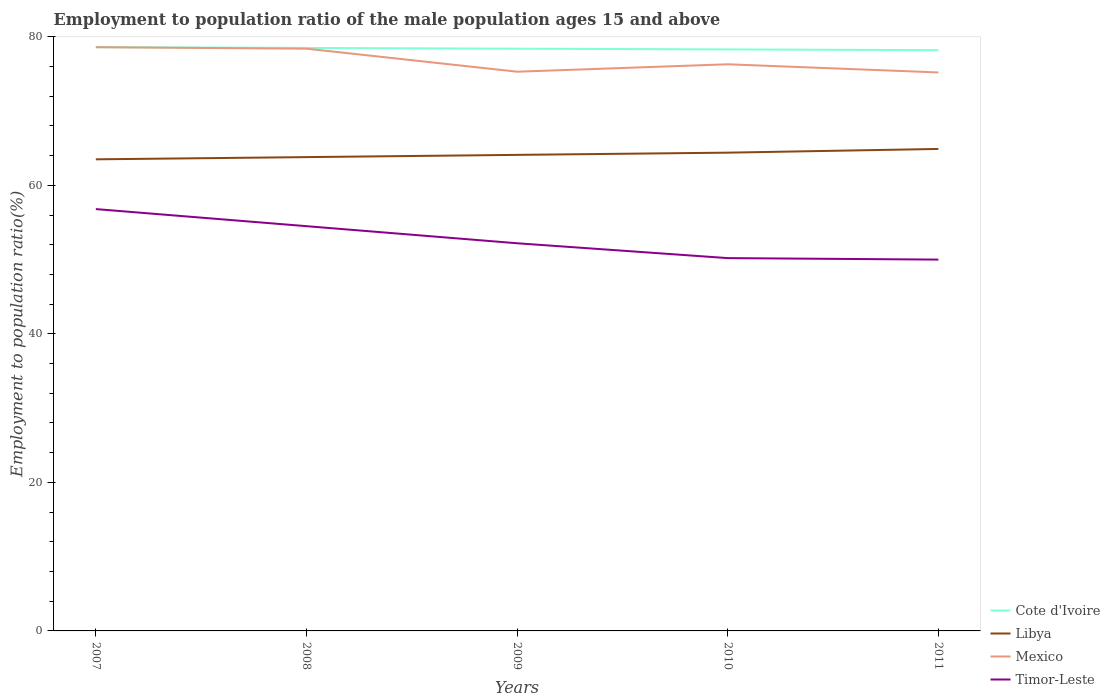How many different coloured lines are there?
Provide a succinct answer. 4. Does the line corresponding to Libya intersect with the line corresponding to Cote d'Ivoire?
Your response must be concise. No. Is the number of lines equal to the number of legend labels?
Provide a short and direct response. Yes. Across all years, what is the maximum employment to population ratio in Mexico?
Keep it short and to the point. 75.2. What is the total employment to population ratio in Mexico in the graph?
Ensure brevity in your answer.  3.1. What is the difference between the highest and the second highest employment to population ratio in Timor-Leste?
Your response must be concise. 6.8. What is the difference between the highest and the lowest employment to population ratio in Cote d'Ivoire?
Your answer should be very brief. 3. How many lines are there?
Offer a terse response. 4. Does the graph contain grids?
Your answer should be very brief. No. How many legend labels are there?
Your answer should be compact. 4. What is the title of the graph?
Provide a succinct answer. Employment to population ratio of the male population ages 15 and above. Does "Kiribati" appear as one of the legend labels in the graph?
Ensure brevity in your answer.  No. What is the label or title of the X-axis?
Your response must be concise. Years. What is the label or title of the Y-axis?
Ensure brevity in your answer.  Employment to population ratio(%). What is the Employment to population ratio(%) of Cote d'Ivoire in 2007?
Ensure brevity in your answer.  78.6. What is the Employment to population ratio(%) in Libya in 2007?
Offer a very short reply. 63.5. What is the Employment to population ratio(%) of Mexico in 2007?
Provide a short and direct response. 78.6. What is the Employment to population ratio(%) of Timor-Leste in 2007?
Your answer should be very brief. 56.8. What is the Employment to population ratio(%) in Cote d'Ivoire in 2008?
Make the answer very short. 78.5. What is the Employment to population ratio(%) in Libya in 2008?
Make the answer very short. 63.8. What is the Employment to population ratio(%) of Mexico in 2008?
Ensure brevity in your answer.  78.4. What is the Employment to population ratio(%) of Timor-Leste in 2008?
Provide a succinct answer. 54.5. What is the Employment to population ratio(%) in Cote d'Ivoire in 2009?
Ensure brevity in your answer.  78.4. What is the Employment to population ratio(%) in Libya in 2009?
Offer a very short reply. 64.1. What is the Employment to population ratio(%) of Mexico in 2009?
Your answer should be very brief. 75.3. What is the Employment to population ratio(%) of Timor-Leste in 2009?
Make the answer very short. 52.2. What is the Employment to population ratio(%) in Cote d'Ivoire in 2010?
Your response must be concise. 78.3. What is the Employment to population ratio(%) in Libya in 2010?
Provide a succinct answer. 64.4. What is the Employment to population ratio(%) of Mexico in 2010?
Offer a very short reply. 76.3. What is the Employment to population ratio(%) in Timor-Leste in 2010?
Make the answer very short. 50.2. What is the Employment to population ratio(%) of Cote d'Ivoire in 2011?
Offer a very short reply. 78.2. What is the Employment to population ratio(%) in Libya in 2011?
Give a very brief answer. 64.9. What is the Employment to population ratio(%) in Mexico in 2011?
Your answer should be very brief. 75.2. Across all years, what is the maximum Employment to population ratio(%) of Cote d'Ivoire?
Provide a succinct answer. 78.6. Across all years, what is the maximum Employment to population ratio(%) in Libya?
Ensure brevity in your answer.  64.9. Across all years, what is the maximum Employment to population ratio(%) of Mexico?
Your answer should be very brief. 78.6. Across all years, what is the maximum Employment to population ratio(%) of Timor-Leste?
Your answer should be very brief. 56.8. Across all years, what is the minimum Employment to population ratio(%) of Cote d'Ivoire?
Provide a succinct answer. 78.2. Across all years, what is the minimum Employment to population ratio(%) in Libya?
Ensure brevity in your answer.  63.5. Across all years, what is the minimum Employment to population ratio(%) of Mexico?
Give a very brief answer. 75.2. Across all years, what is the minimum Employment to population ratio(%) of Timor-Leste?
Give a very brief answer. 50. What is the total Employment to population ratio(%) of Cote d'Ivoire in the graph?
Make the answer very short. 392. What is the total Employment to population ratio(%) in Libya in the graph?
Provide a short and direct response. 320.7. What is the total Employment to population ratio(%) in Mexico in the graph?
Your answer should be compact. 383.8. What is the total Employment to population ratio(%) in Timor-Leste in the graph?
Your answer should be very brief. 263.7. What is the difference between the Employment to population ratio(%) in Cote d'Ivoire in 2007 and that in 2008?
Give a very brief answer. 0.1. What is the difference between the Employment to population ratio(%) of Libya in 2007 and that in 2008?
Your response must be concise. -0.3. What is the difference between the Employment to population ratio(%) in Mexico in 2007 and that in 2008?
Offer a terse response. 0.2. What is the difference between the Employment to population ratio(%) in Cote d'Ivoire in 2007 and that in 2009?
Your response must be concise. 0.2. What is the difference between the Employment to population ratio(%) of Mexico in 2007 and that in 2009?
Offer a very short reply. 3.3. What is the difference between the Employment to population ratio(%) in Cote d'Ivoire in 2007 and that in 2010?
Provide a short and direct response. 0.3. What is the difference between the Employment to population ratio(%) of Mexico in 2007 and that in 2010?
Make the answer very short. 2.3. What is the difference between the Employment to population ratio(%) in Timor-Leste in 2007 and that in 2010?
Your answer should be compact. 6.6. What is the difference between the Employment to population ratio(%) of Cote d'Ivoire in 2007 and that in 2011?
Your response must be concise. 0.4. What is the difference between the Employment to population ratio(%) of Libya in 2007 and that in 2011?
Your answer should be compact. -1.4. What is the difference between the Employment to population ratio(%) in Mexico in 2007 and that in 2011?
Offer a terse response. 3.4. What is the difference between the Employment to population ratio(%) of Libya in 2008 and that in 2009?
Your answer should be very brief. -0.3. What is the difference between the Employment to population ratio(%) in Mexico in 2008 and that in 2009?
Give a very brief answer. 3.1. What is the difference between the Employment to population ratio(%) in Timor-Leste in 2008 and that in 2009?
Make the answer very short. 2.3. What is the difference between the Employment to population ratio(%) in Cote d'Ivoire in 2008 and that in 2010?
Your answer should be very brief. 0.2. What is the difference between the Employment to population ratio(%) of Libya in 2008 and that in 2010?
Give a very brief answer. -0.6. What is the difference between the Employment to population ratio(%) of Mexico in 2008 and that in 2010?
Your answer should be very brief. 2.1. What is the difference between the Employment to population ratio(%) in Cote d'Ivoire in 2008 and that in 2011?
Offer a very short reply. 0.3. What is the difference between the Employment to population ratio(%) of Mexico in 2008 and that in 2011?
Provide a short and direct response. 3.2. What is the difference between the Employment to population ratio(%) of Timor-Leste in 2008 and that in 2011?
Your response must be concise. 4.5. What is the difference between the Employment to population ratio(%) of Mexico in 2009 and that in 2010?
Your answer should be very brief. -1. What is the difference between the Employment to population ratio(%) in Timor-Leste in 2009 and that in 2010?
Make the answer very short. 2. What is the difference between the Employment to population ratio(%) in Timor-Leste in 2009 and that in 2011?
Offer a terse response. 2.2. What is the difference between the Employment to population ratio(%) in Cote d'Ivoire in 2010 and that in 2011?
Your response must be concise. 0.1. What is the difference between the Employment to population ratio(%) of Cote d'Ivoire in 2007 and the Employment to population ratio(%) of Timor-Leste in 2008?
Ensure brevity in your answer.  24.1. What is the difference between the Employment to population ratio(%) of Libya in 2007 and the Employment to population ratio(%) of Mexico in 2008?
Make the answer very short. -14.9. What is the difference between the Employment to population ratio(%) in Libya in 2007 and the Employment to population ratio(%) in Timor-Leste in 2008?
Give a very brief answer. 9. What is the difference between the Employment to population ratio(%) in Mexico in 2007 and the Employment to population ratio(%) in Timor-Leste in 2008?
Ensure brevity in your answer.  24.1. What is the difference between the Employment to population ratio(%) in Cote d'Ivoire in 2007 and the Employment to population ratio(%) in Mexico in 2009?
Your response must be concise. 3.3. What is the difference between the Employment to population ratio(%) of Cote d'Ivoire in 2007 and the Employment to population ratio(%) of Timor-Leste in 2009?
Ensure brevity in your answer.  26.4. What is the difference between the Employment to population ratio(%) in Libya in 2007 and the Employment to population ratio(%) in Mexico in 2009?
Offer a terse response. -11.8. What is the difference between the Employment to population ratio(%) of Libya in 2007 and the Employment to population ratio(%) of Timor-Leste in 2009?
Ensure brevity in your answer.  11.3. What is the difference between the Employment to population ratio(%) of Mexico in 2007 and the Employment to population ratio(%) of Timor-Leste in 2009?
Your answer should be very brief. 26.4. What is the difference between the Employment to population ratio(%) of Cote d'Ivoire in 2007 and the Employment to population ratio(%) of Libya in 2010?
Provide a short and direct response. 14.2. What is the difference between the Employment to population ratio(%) of Cote d'Ivoire in 2007 and the Employment to population ratio(%) of Timor-Leste in 2010?
Your response must be concise. 28.4. What is the difference between the Employment to population ratio(%) of Mexico in 2007 and the Employment to population ratio(%) of Timor-Leste in 2010?
Ensure brevity in your answer.  28.4. What is the difference between the Employment to population ratio(%) in Cote d'Ivoire in 2007 and the Employment to population ratio(%) in Mexico in 2011?
Your answer should be compact. 3.4. What is the difference between the Employment to population ratio(%) in Cote d'Ivoire in 2007 and the Employment to population ratio(%) in Timor-Leste in 2011?
Keep it short and to the point. 28.6. What is the difference between the Employment to population ratio(%) of Libya in 2007 and the Employment to population ratio(%) of Mexico in 2011?
Give a very brief answer. -11.7. What is the difference between the Employment to population ratio(%) of Mexico in 2007 and the Employment to population ratio(%) of Timor-Leste in 2011?
Keep it short and to the point. 28.6. What is the difference between the Employment to population ratio(%) in Cote d'Ivoire in 2008 and the Employment to population ratio(%) in Libya in 2009?
Give a very brief answer. 14.4. What is the difference between the Employment to population ratio(%) of Cote d'Ivoire in 2008 and the Employment to population ratio(%) of Timor-Leste in 2009?
Offer a very short reply. 26.3. What is the difference between the Employment to population ratio(%) of Libya in 2008 and the Employment to population ratio(%) of Mexico in 2009?
Offer a terse response. -11.5. What is the difference between the Employment to population ratio(%) of Libya in 2008 and the Employment to population ratio(%) of Timor-Leste in 2009?
Provide a short and direct response. 11.6. What is the difference between the Employment to population ratio(%) in Mexico in 2008 and the Employment to population ratio(%) in Timor-Leste in 2009?
Your response must be concise. 26.2. What is the difference between the Employment to population ratio(%) in Cote d'Ivoire in 2008 and the Employment to population ratio(%) in Timor-Leste in 2010?
Provide a succinct answer. 28.3. What is the difference between the Employment to population ratio(%) in Libya in 2008 and the Employment to population ratio(%) in Timor-Leste in 2010?
Give a very brief answer. 13.6. What is the difference between the Employment to population ratio(%) of Mexico in 2008 and the Employment to population ratio(%) of Timor-Leste in 2010?
Ensure brevity in your answer.  28.2. What is the difference between the Employment to population ratio(%) of Cote d'Ivoire in 2008 and the Employment to population ratio(%) of Libya in 2011?
Provide a succinct answer. 13.6. What is the difference between the Employment to population ratio(%) of Cote d'Ivoire in 2008 and the Employment to population ratio(%) of Mexico in 2011?
Keep it short and to the point. 3.3. What is the difference between the Employment to population ratio(%) in Cote d'Ivoire in 2008 and the Employment to population ratio(%) in Timor-Leste in 2011?
Provide a short and direct response. 28.5. What is the difference between the Employment to population ratio(%) in Mexico in 2008 and the Employment to population ratio(%) in Timor-Leste in 2011?
Provide a short and direct response. 28.4. What is the difference between the Employment to population ratio(%) in Cote d'Ivoire in 2009 and the Employment to population ratio(%) in Libya in 2010?
Ensure brevity in your answer.  14. What is the difference between the Employment to population ratio(%) in Cote d'Ivoire in 2009 and the Employment to population ratio(%) in Mexico in 2010?
Give a very brief answer. 2.1. What is the difference between the Employment to population ratio(%) in Cote d'Ivoire in 2009 and the Employment to population ratio(%) in Timor-Leste in 2010?
Provide a short and direct response. 28.2. What is the difference between the Employment to population ratio(%) of Libya in 2009 and the Employment to population ratio(%) of Mexico in 2010?
Provide a short and direct response. -12.2. What is the difference between the Employment to population ratio(%) of Mexico in 2009 and the Employment to population ratio(%) of Timor-Leste in 2010?
Keep it short and to the point. 25.1. What is the difference between the Employment to population ratio(%) of Cote d'Ivoire in 2009 and the Employment to population ratio(%) of Timor-Leste in 2011?
Your answer should be compact. 28.4. What is the difference between the Employment to population ratio(%) of Libya in 2009 and the Employment to population ratio(%) of Timor-Leste in 2011?
Ensure brevity in your answer.  14.1. What is the difference between the Employment to population ratio(%) in Mexico in 2009 and the Employment to population ratio(%) in Timor-Leste in 2011?
Your answer should be very brief. 25.3. What is the difference between the Employment to population ratio(%) of Cote d'Ivoire in 2010 and the Employment to population ratio(%) of Mexico in 2011?
Keep it short and to the point. 3.1. What is the difference between the Employment to population ratio(%) of Cote d'Ivoire in 2010 and the Employment to population ratio(%) of Timor-Leste in 2011?
Offer a very short reply. 28.3. What is the difference between the Employment to population ratio(%) in Libya in 2010 and the Employment to population ratio(%) in Timor-Leste in 2011?
Give a very brief answer. 14.4. What is the difference between the Employment to population ratio(%) in Mexico in 2010 and the Employment to population ratio(%) in Timor-Leste in 2011?
Keep it short and to the point. 26.3. What is the average Employment to population ratio(%) in Cote d'Ivoire per year?
Provide a short and direct response. 78.4. What is the average Employment to population ratio(%) of Libya per year?
Your answer should be very brief. 64.14. What is the average Employment to population ratio(%) in Mexico per year?
Offer a very short reply. 76.76. What is the average Employment to population ratio(%) in Timor-Leste per year?
Provide a succinct answer. 52.74. In the year 2007, what is the difference between the Employment to population ratio(%) of Cote d'Ivoire and Employment to population ratio(%) of Timor-Leste?
Ensure brevity in your answer.  21.8. In the year 2007, what is the difference between the Employment to population ratio(%) of Libya and Employment to population ratio(%) of Mexico?
Give a very brief answer. -15.1. In the year 2007, what is the difference between the Employment to population ratio(%) in Mexico and Employment to population ratio(%) in Timor-Leste?
Your response must be concise. 21.8. In the year 2008, what is the difference between the Employment to population ratio(%) of Cote d'Ivoire and Employment to population ratio(%) of Libya?
Ensure brevity in your answer.  14.7. In the year 2008, what is the difference between the Employment to population ratio(%) of Cote d'Ivoire and Employment to population ratio(%) of Mexico?
Offer a terse response. 0.1. In the year 2008, what is the difference between the Employment to population ratio(%) in Libya and Employment to population ratio(%) in Mexico?
Keep it short and to the point. -14.6. In the year 2008, what is the difference between the Employment to population ratio(%) of Mexico and Employment to population ratio(%) of Timor-Leste?
Ensure brevity in your answer.  23.9. In the year 2009, what is the difference between the Employment to population ratio(%) of Cote d'Ivoire and Employment to population ratio(%) of Timor-Leste?
Make the answer very short. 26.2. In the year 2009, what is the difference between the Employment to population ratio(%) of Libya and Employment to population ratio(%) of Mexico?
Your answer should be compact. -11.2. In the year 2009, what is the difference between the Employment to population ratio(%) in Libya and Employment to population ratio(%) in Timor-Leste?
Your answer should be very brief. 11.9. In the year 2009, what is the difference between the Employment to population ratio(%) in Mexico and Employment to population ratio(%) in Timor-Leste?
Provide a succinct answer. 23.1. In the year 2010, what is the difference between the Employment to population ratio(%) in Cote d'Ivoire and Employment to population ratio(%) in Libya?
Offer a terse response. 13.9. In the year 2010, what is the difference between the Employment to population ratio(%) of Cote d'Ivoire and Employment to population ratio(%) of Timor-Leste?
Ensure brevity in your answer.  28.1. In the year 2010, what is the difference between the Employment to population ratio(%) in Mexico and Employment to population ratio(%) in Timor-Leste?
Make the answer very short. 26.1. In the year 2011, what is the difference between the Employment to population ratio(%) of Cote d'Ivoire and Employment to population ratio(%) of Libya?
Ensure brevity in your answer.  13.3. In the year 2011, what is the difference between the Employment to population ratio(%) of Cote d'Ivoire and Employment to population ratio(%) of Timor-Leste?
Offer a terse response. 28.2. In the year 2011, what is the difference between the Employment to population ratio(%) of Libya and Employment to population ratio(%) of Mexico?
Provide a short and direct response. -10.3. In the year 2011, what is the difference between the Employment to population ratio(%) of Libya and Employment to population ratio(%) of Timor-Leste?
Provide a short and direct response. 14.9. In the year 2011, what is the difference between the Employment to population ratio(%) in Mexico and Employment to population ratio(%) in Timor-Leste?
Ensure brevity in your answer.  25.2. What is the ratio of the Employment to population ratio(%) in Cote d'Ivoire in 2007 to that in 2008?
Provide a short and direct response. 1. What is the ratio of the Employment to population ratio(%) of Libya in 2007 to that in 2008?
Your response must be concise. 1. What is the ratio of the Employment to population ratio(%) in Timor-Leste in 2007 to that in 2008?
Provide a short and direct response. 1.04. What is the ratio of the Employment to population ratio(%) of Libya in 2007 to that in 2009?
Make the answer very short. 0.99. What is the ratio of the Employment to population ratio(%) of Mexico in 2007 to that in 2009?
Provide a succinct answer. 1.04. What is the ratio of the Employment to population ratio(%) of Timor-Leste in 2007 to that in 2009?
Make the answer very short. 1.09. What is the ratio of the Employment to population ratio(%) in Cote d'Ivoire in 2007 to that in 2010?
Offer a terse response. 1. What is the ratio of the Employment to population ratio(%) in Mexico in 2007 to that in 2010?
Provide a succinct answer. 1.03. What is the ratio of the Employment to population ratio(%) in Timor-Leste in 2007 to that in 2010?
Your response must be concise. 1.13. What is the ratio of the Employment to population ratio(%) in Libya in 2007 to that in 2011?
Ensure brevity in your answer.  0.98. What is the ratio of the Employment to population ratio(%) in Mexico in 2007 to that in 2011?
Keep it short and to the point. 1.05. What is the ratio of the Employment to population ratio(%) in Timor-Leste in 2007 to that in 2011?
Offer a terse response. 1.14. What is the ratio of the Employment to population ratio(%) in Cote d'Ivoire in 2008 to that in 2009?
Offer a terse response. 1. What is the ratio of the Employment to population ratio(%) of Libya in 2008 to that in 2009?
Offer a terse response. 1. What is the ratio of the Employment to population ratio(%) in Mexico in 2008 to that in 2009?
Provide a succinct answer. 1.04. What is the ratio of the Employment to population ratio(%) of Timor-Leste in 2008 to that in 2009?
Make the answer very short. 1.04. What is the ratio of the Employment to population ratio(%) of Mexico in 2008 to that in 2010?
Your answer should be compact. 1.03. What is the ratio of the Employment to population ratio(%) in Timor-Leste in 2008 to that in 2010?
Provide a short and direct response. 1.09. What is the ratio of the Employment to population ratio(%) of Cote d'Ivoire in 2008 to that in 2011?
Offer a very short reply. 1. What is the ratio of the Employment to population ratio(%) in Libya in 2008 to that in 2011?
Offer a very short reply. 0.98. What is the ratio of the Employment to population ratio(%) of Mexico in 2008 to that in 2011?
Your answer should be compact. 1.04. What is the ratio of the Employment to population ratio(%) in Timor-Leste in 2008 to that in 2011?
Make the answer very short. 1.09. What is the ratio of the Employment to population ratio(%) in Cote d'Ivoire in 2009 to that in 2010?
Keep it short and to the point. 1. What is the ratio of the Employment to population ratio(%) in Libya in 2009 to that in 2010?
Provide a short and direct response. 1. What is the ratio of the Employment to population ratio(%) of Mexico in 2009 to that in 2010?
Your answer should be very brief. 0.99. What is the ratio of the Employment to population ratio(%) of Timor-Leste in 2009 to that in 2010?
Ensure brevity in your answer.  1.04. What is the ratio of the Employment to population ratio(%) in Cote d'Ivoire in 2009 to that in 2011?
Provide a short and direct response. 1. What is the ratio of the Employment to population ratio(%) of Libya in 2009 to that in 2011?
Make the answer very short. 0.99. What is the ratio of the Employment to population ratio(%) in Mexico in 2009 to that in 2011?
Your answer should be compact. 1. What is the ratio of the Employment to population ratio(%) in Timor-Leste in 2009 to that in 2011?
Give a very brief answer. 1.04. What is the ratio of the Employment to population ratio(%) of Cote d'Ivoire in 2010 to that in 2011?
Keep it short and to the point. 1. What is the ratio of the Employment to population ratio(%) in Libya in 2010 to that in 2011?
Offer a very short reply. 0.99. What is the ratio of the Employment to population ratio(%) of Mexico in 2010 to that in 2011?
Make the answer very short. 1.01. What is the ratio of the Employment to population ratio(%) of Timor-Leste in 2010 to that in 2011?
Offer a very short reply. 1. What is the difference between the highest and the second highest Employment to population ratio(%) in Libya?
Your response must be concise. 0.5. What is the difference between the highest and the second highest Employment to population ratio(%) in Mexico?
Ensure brevity in your answer.  0.2. What is the difference between the highest and the lowest Employment to population ratio(%) in Libya?
Offer a very short reply. 1.4. What is the difference between the highest and the lowest Employment to population ratio(%) in Mexico?
Make the answer very short. 3.4. What is the difference between the highest and the lowest Employment to population ratio(%) in Timor-Leste?
Your answer should be very brief. 6.8. 